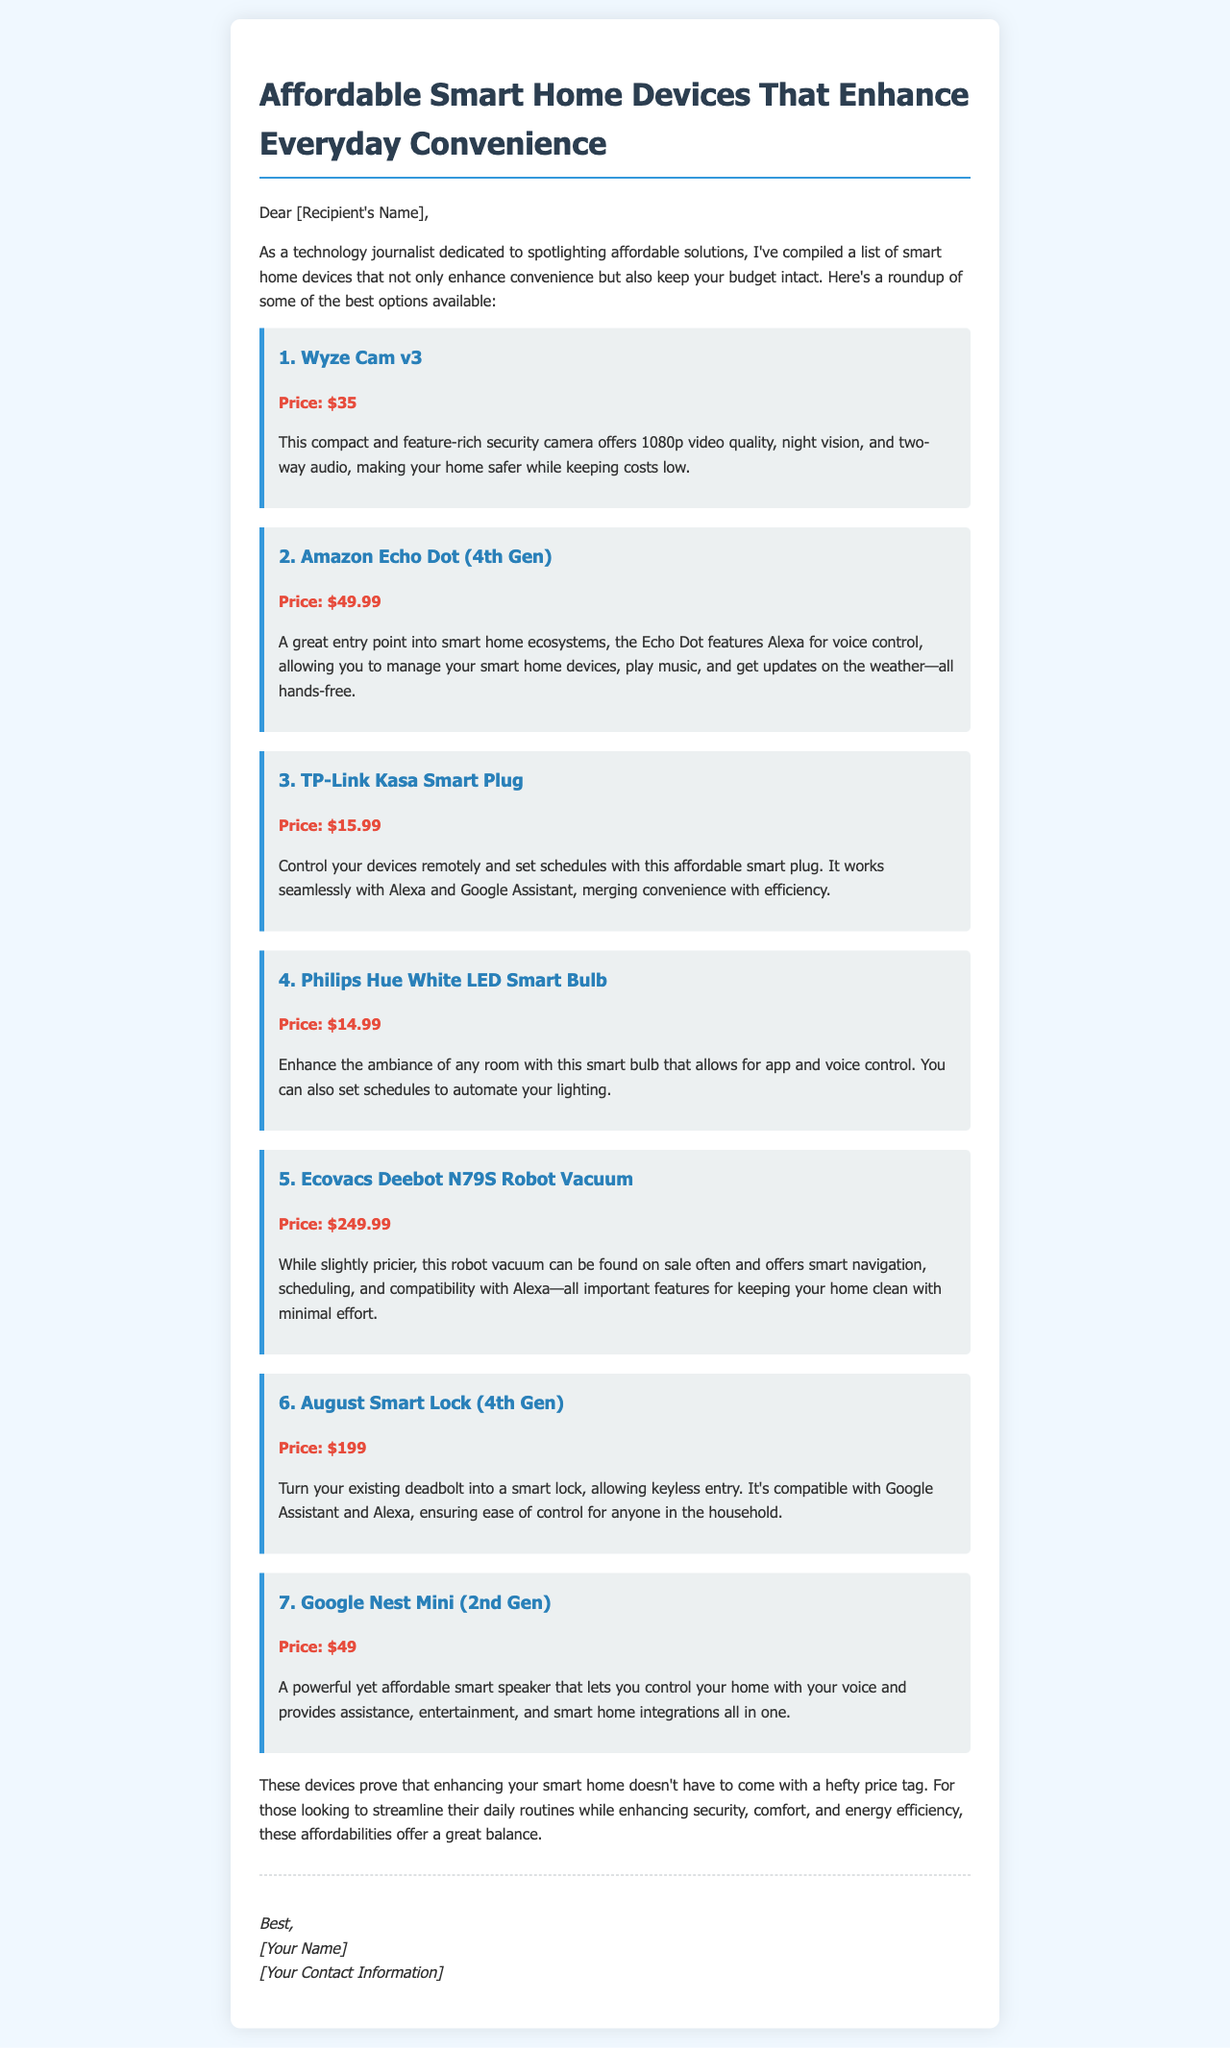what is the price of Wyze Cam v3? The price of Wyze Cam v3 is specifically mentioned in the document as $35.
Answer: $35 how many smart home devices are listed in the email? The email lists a total of seven smart home devices in the roundup section.
Answer: 7 which device allows for voice control and is priced at $49.99? The device that allows for voice control and is priced at $49.99 is the Amazon Echo Dot (4th Gen).
Answer: Amazon Echo Dot (4th Gen) what is the main feature of the TP-Link Kasa Smart Plug? The main feature of the TP-Link Kasa Smart Plug is its ability to control devices remotely and set schedules.
Answer: Control devices remotely is the Ecovacs Deebot N79S considered an affordable smart home device? Although slightly pricier at $249.99, it is often found on sale, suggesting it can still be seen as an affordable option for a robot vacuum.
Answer: Yes what common assistant is the August Smart Lock compatible with? The August Smart Lock is compatible with both Google Assistant and Alexa.
Answer: Google Assistant and Alexa what is the purpose of the email? The purpose of the email is to highlight affordable smart home devices that enhance convenience without exceeding a budget.
Answer: Highlight affordable devices 